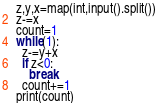<code> <loc_0><loc_0><loc_500><loc_500><_Python_>z,y,x=map(int,input().split())
z-=x
count=1
while(1):
  z-=y+x
  if z<0:
    break
  count+=1
print(count)</code> 